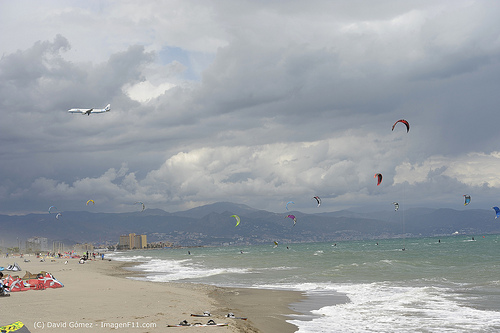Please provide a short description for this region: [0.03, 0.63, 0.32, 0.67]. The region with the bounding box coordinates [0.03, 0.63, 0.32, 0.67] consists of a line of buildings on the coast. 